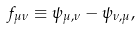Convert formula to latex. <formula><loc_0><loc_0><loc_500><loc_500>f _ { \mu \nu } \equiv \psi _ { \mu , \nu } - \psi _ { \nu , \mu } ,</formula> 